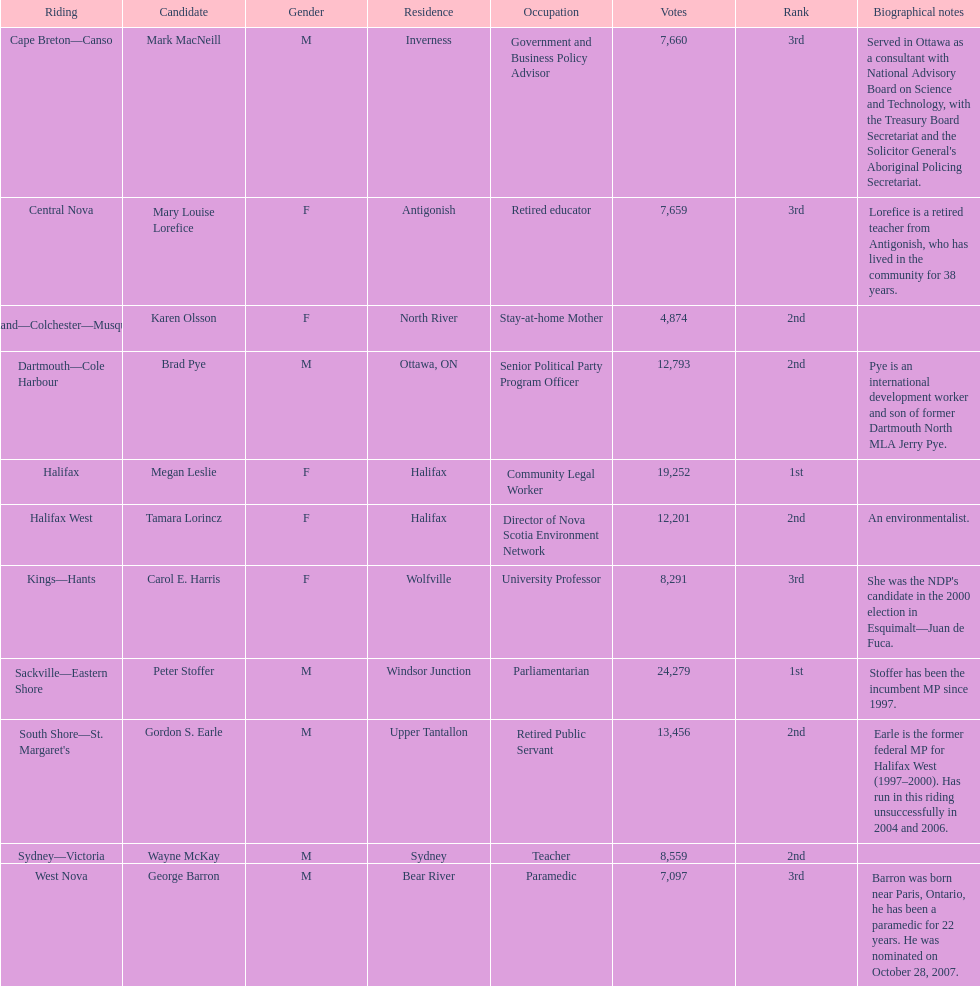Write the full table. {'header': ['Riding', 'Candidate', 'Gender', 'Residence', 'Occupation', 'Votes', 'Rank', 'Biographical notes'], 'rows': [['Cape Breton—Canso', 'Mark MacNeill', 'M', 'Inverness', 'Government and Business Policy Advisor', '7,660', '3rd', "Served in Ottawa as a consultant with National Advisory Board on Science and Technology, with the Treasury Board Secretariat and the Solicitor General's Aboriginal Policing Secretariat."], ['Central Nova', 'Mary Louise Lorefice', 'F', 'Antigonish', 'Retired educator', '7,659', '3rd', 'Lorefice is a retired teacher from Antigonish, who has lived in the community for 38 years.'], ['Cumberland—Colchester—Musquodoboit Valley', 'Karen Olsson', 'F', 'North River', 'Stay-at-home Mother', '4,874', '2nd', ''], ['Dartmouth—Cole Harbour', 'Brad Pye', 'M', 'Ottawa, ON', 'Senior Political Party Program Officer', '12,793', '2nd', 'Pye is an international development worker and son of former Dartmouth North MLA Jerry Pye.'], ['Halifax', 'Megan Leslie', 'F', 'Halifax', 'Community Legal Worker', '19,252', '1st', ''], ['Halifax West', 'Tamara Lorincz', 'F', 'Halifax', 'Director of Nova Scotia Environment Network', '12,201', '2nd', 'An environmentalist.'], ['Kings—Hants', 'Carol E. Harris', 'F', 'Wolfville', 'University Professor', '8,291', '3rd', "She was the NDP's candidate in the 2000 election in Esquimalt—Juan de Fuca."], ['Sackville—Eastern Shore', 'Peter Stoffer', 'M', 'Windsor Junction', 'Parliamentarian', '24,279', '1st', 'Stoffer has been the incumbent MP since 1997.'], ["South Shore—St. Margaret's", 'Gordon S. Earle', 'M', 'Upper Tantallon', 'Retired Public Servant', '13,456', '2nd', 'Earle is the former federal MP for Halifax West (1997–2000). Has run in this riding unsuccessfully in 2004 and 2006.'], ['Sydney—Victoria', 'Wayne McKay', 'M', 'Sydney', 'Teacher', '8,559', '2nd', ''], ['West Nova', 'George Barron', 'M', 'Bear River', 'Paramedic', '7,097', '3rd', 'Barron was born near Paris, Ontario, he has been a paramedic for 22 years. He was nominated on October 28, 2007.']]} What is the first riding? Cape Breton-Canso. 